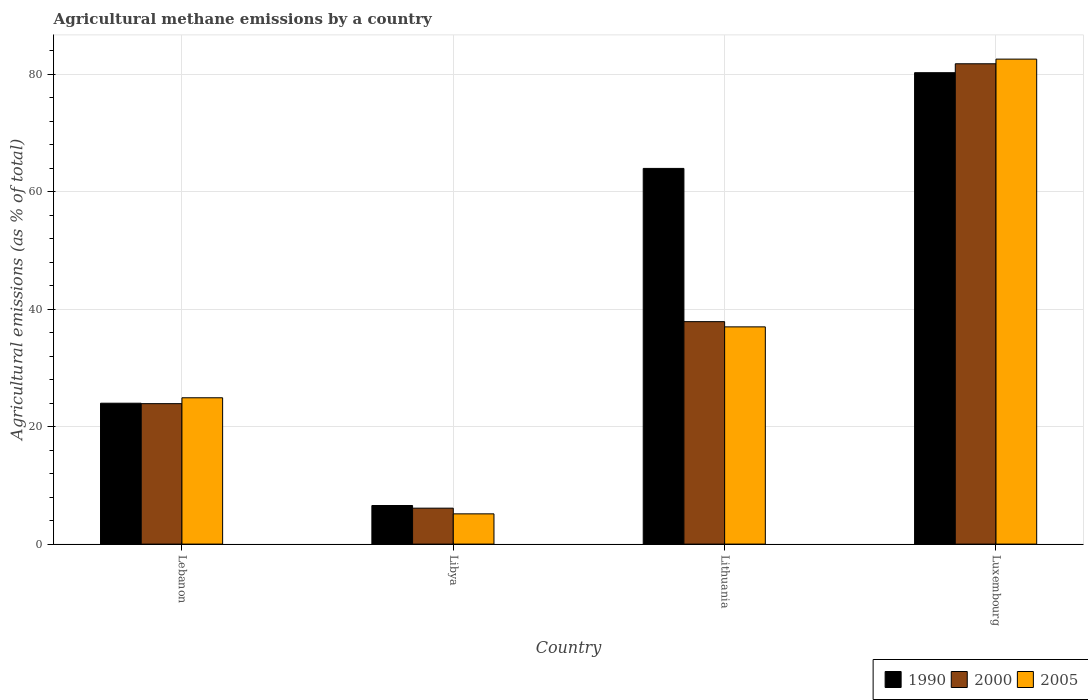Are the number of bars on each tick of the X-axis equal?
Keep it short and to the point. Yes. What is the label of the 4th group of bars from the left?
Provide a succinct answer. Luxembourg. In how many cases, is the number of bars for a given country not equal to the number of legend labels?
Offer a terse response. 0. What is the amount of agricultural methane emitted in 1990 in Luxembourg?
Provide a succinct answer. 80.22. Across all countries, what is the maximum amount of agricultural methane emitted in 2000?
Keep it short and to the point. 81.74. Across all countries, what is the minimum amount of agricultural methane emitted in 1990?
Your answer should be compact. 6.57. In which country was the amount of agricultural methane emitted in 2005 maximum?
Your answer should be very brief. Luxembourg. In which country was the amount of agricultural methane emitted in 2005 minimum?
Make the answer very short. Libya. What is the total amount of agricultural methane emitted in 2000 in the graph?
Provide a short and direct response. 149.62. What is the difference between the amount of agricultural methane emitted in 2005 in Libya and that in Lithuania?
Give a very brief answer. -31.82. What is the difference between the amount of agricultural methane emitted in 2005 in Luxembourg and the amount of agricultural methane emitted in 1990 in Lithuania?
Your answer should be compact. 18.6. What is the average amount of agricultural methane emitted in 2005 per country?
Your answer should be compact. 37.39. What is the difference between the amount of agricultural methane emitted of/in 2005 and amount of agricultural methane emitted of/in 1990 in Lithuania?
Offer a very short reply. -26.97. In how many countries, is the amount of agricultural methane emitted in 2000 greater than 60 %?
Your answer should be compact. 1. What is the ratio of the amount of agricultural methane emitted in 2000 in Libya to that in Lithuania?
Offer a terse response. 0.16. Is the amount of agricultural methane emitted in 1990 in Lebanon less than that in Lithuania?
Offer a very short reply. Yes. What is the difference between the highest and the second highest amount of agricultural methane emitted in 2005?
Provide a short and direct response. -57.63. What is the difference between the highest and the lowest amount of agricultural methane emitted in 2005?
Your response must be concise. 77.39. Is the sum of the amount of agricultural methane emitted in 1990 in Lithuania and Luxembourg greater than the maximum amount of agricultural methane emitted in 2000 across all countries?
Provide a succinct answer. Yes. What does the 1st bar from the left in Luxembourg represents?
Give a very brief answer. 1990. Is it the case that in every country, the sum of the amount of agricultural methane emitted in 2000 and amount of agricultural methane emitted in 1990 is greater than the amount of agricultural methane emitted in 2005?
Ensure brevity in your answer.  Yes. How many bars are there?
Ensure brevity in your answer.  12. Are all the bars in the graph horizontal?
Your answer should be very brief. No. How many countries are there in the graph?
Offer a very short reply. 4. What is the difference between two consecutive major ticks on the Y-axis?
Keep it short and to the point. 20. Are the values on the major ticks of Y-axis written in scientific E-notation?
Your answer should be very brief. No. Does the graph contain any zero values?
Provide a succinct answer. No. Does the graph contain grids?
Offer a very short reply. Yes. How are the legend labels stacked?
Keep it short and to the point. Horizontal. What is the title of the graph?
Make the answer very short. Agricultural methane emissions by a country. What is the label or title of the X-axis?
Give a very brief answer. Country. What is the label or title of the Y-axis?
Keep it short and to the point. Agricultural emissions (as % of total). What is the Agricultural emissions (as % of total) in 1990 in Lebanon?
Keep it short and to the point. 23.98. What is the Agricultural emissions (as % of total) of 2000 in Lebanon?
Give a very brief answer. 23.9. What is the Agricultural emissions (as % of total) of 2005 in Lebanon?
Offer a terse response. 24.9. What is the Agricultural emissions (as % of total) in 1990 in Libya?
Offer a very short reply. 6.57. What is the Agricultural emissions (as % of total) of 2000 in Libya?
Offer a very short reply. 6.12. What is the Agricultural emissions (as % of total) of 2005 in Libya?
Offer a very short reply. 5.15. What is the Agricultural emissions (as % of total) in 1990 in Lithuania?
Make the answer very short. 63.93. What is the Agricultural emissions (as % of total) in 2000 in Lithuania?
Offer a terse response. 37.86. What is the Agricultural emissions (as % of total) in 2005 in Lithuania?
Give a very brief answer. 36.97. What is the Agricultural emissions (as % of total) of 1990 in Luxembourg?
Provide a short and direct response. 80.22. What is the Agricultural emissions (as % of total) in 2000 in Luxembourg?
Ensure brevity in your answer.  81.74. What is the Agricultural emissions (as % of total) in 2005 in Luxembourg?
Make the answer very short. 82.53. Across all countries, what is the maximum Agricultural emissions (as % of total) of 1990?
Your answer should be compact. 80.22. Across all countries, what is the maximum Agricultural emissions (as % of total) in 2000?
Your answer should be compact. 81.74. Across all countries, what is the maximum Agricultural emissions (as % of total) in 2005?
Make the answer very short. 82.53. Across all countries, what is the minimum Agricultural emissions (as % of total) in 1990?
Make the answer very short. 6.57. Across all countries, what is the minimum Agricultural emissions (as % of total) of 2000?
Provide a short and direct response. 6.12. Across all countries, what is the minimum Agricultural emissions (as % of total) of 2005?
Your answer should be compact. 5.15. What is the total Agricultural emissions (as % of total) of 1990 in the graph?
Your response must be concise. 174.7. What is the total Agricultural emissions (as % of total) in 2000 in the graph?
Your response must be concise. 149.62. What is the total Agricultural emissions (as % of total) of 2005 in the graph?
Your answer should be very brief. 149.55. What is the difference between the Agricultural emissions (as % of total) in 1990 in Lebanon and that in Libya?
Your answer should be very brief. 17.41. What is the difference between the Agricultural emissions (as % of total) of 2000 in Lebanon and that in Libya?
Your answer should be very brief. 17.79. What is the difference between the Agricultural emissions (as % of total) of 2005 in Lebanon and that in Libya?
Make the answer very short. 19.76. What is the difference between the Agricultural emissions (as % of total) of 1990 in Lebanon and that in Lithuania?
Provide a succinct answer. -39.96. What is the difference between the Agricultural emissions (as % of total) of 2000 in Lebanon and that in Lithuania?
Offer a very short reply. -13.95. What is the difference between the Agricultural emissions (as % of total) in 2005 in Lebanon and that in Lithuania?
Offer a terse response. -12.07. What is the difference between the Agricultural emissions (as % of total) in 1990 in Lebanon and that in Luxembourg?
Your answer should be very brief. -56.25. What is the difference between the Agricultural emissions (as % of total) in 2000 in Lebanon and that in Luxembourg?
Provide a succinct answer. -57.84. What is the difference between the Agricultural emissions (as % of total) in 2005 in Lebanon and that in Luxembourg?
Provide a succinct answer. -57.63. What is the difference between the Agricultural emissions (as % of total) of 1990 in Libya and that in Lithuania?
Offer a very short reply. -57.37. What is the difference between the Agricultural emissions (as % of total) of 2000 in Libya and that in Lithuania?
Your response must be concise. -31.74. What is the difference between the Agricultural emissions (as % of total) of 2005 in Libya and that in Lithuania?
Offer a terse response. -31.82. What is the difference between the Agricultural emissions (as % of total) in 1990 in Libya and that in Luxembourg?
Keep it short and to the point. -73.65. What is the difference between the Agricultural emissions (as % of total) in 2000 in Libya and that in Luxembourg?
Give a very brief answer. -75.63. What is the difference between the Agricultural emissions (as % of total) of 2005 in Libya and that in Luxembourg?
Offer a very short reply. -77.39. What is the difference between the Agricultural emissions (as % of total) of 1990 in Lithuania and that in Luxembourg?
Make the answer very short. -16.29. What is the difference between the Agricultural emissions (as % of total) in 2000 in Lithuania and that in Luxembourg?
Offer a very short reply. -43.88. What is the difference between the Agricultural emissions (as % of total) in 2005 in Lithuania and that in Luxembourg?
Offer a terse response. -45.56. What is the difference between the Agricultural emissions (as % of total) of 1990 in Lebanon and the Agricultural emissions (as % of total) of 2000 in Libya?
Keep it short and to the point. 17.86. What is the difference between the Agricultural emissions (as % of total) of 1990 in Lebanon and the Agricultural emissions (as % of total) of 2005 in Libya?
Your answer should be compact. 18.83. What is the difference between the Agricultural emissions (as % of total) in 2000 in Lebanon and the Agricultural emissions (as % of total) in 2005 in Libya?
Provide a short and direct response. 18.76. What is the difference between the Agricultural emissions (as % of total) in 1990 in Lebanon and the Agricultural emissions (as % of total) in 2000 in Lithuania?
Your answer should be compact. -13.88. What is the difference between the Agricultural emissions (as % of total) of 1990 in Lebanon and the Agricultural emissions (as % of total) of 2005 in Lithuania?
Make the answer very short. -12.99. What is the difference between the Agricultural emissions (as % of total) in 2000 in Lebanon and the Agricultural emissions (as % of total) in 2005 in Lithuania?
Ensure brevity in your answer.  -13.07. What is the difference between the Agricultural emissions (as % of total) of 1990 in Lebanon and the Agricultural emissions (as % of total) of 2000 in Luxembourg?
Provide a succinct answer. -57.76. What is the difference between the Agricultural emissions (as % of total) of 1990 in Lebanon and the Agricultural emissions (as % of total) of 2005 in Luxembourg?
Ensure brevity in your answer.  -58.56. What is the difference between the Agricultural emissions (as % of total) in 2000 in Lebanon and the Agricultural emissions (as % of total) in 2005 in Luxembourg?
Make the answer very short. -58.63. What is the difference between the Agricultural emissions (as % of total) in 1990 in Libya and the Agricultural emissions (as % of total) in 2000 in Lithuania?
Your answer should be very brief. -31.29. What is the difference between the Agricultural emissions (as % of total) of 1990 in Libya and the Agricultural emissions (as % of total) of 2005 in Lithuania?
Your answer should be compact. -30.4. What is the difference between the Agricultural emissions (as % of total) of 2000 in Libya and the Agricultural emissions (as % of total) of 2005 in Lithuania?
Offer a very short reply. -30.85. What is the difference between the Agricultural emissions (as % of total) in 1990 in Libya and the Agricultural emissions (as % of total) in 2000 in Luxembourg?
Your response must be concise. -75.17. What is the difference between the Agricultural emissions (as % of total) in 1990 in Libya and the Agricultural emissions (as % of total) in 2005 in Luxembourg?
Keep it short and to the point. -75.97. What is the difference between the Agricultural emissions (as % of total) of 2000 in Libya and the Agricultural emissions (as % of total) of 2005 in Luxembourg?
Make the answer very short. -76.42. What is the difference between the Agricultural emissions (as % of total) of 1990 in Lithuania and the Agricultural emissions (as % of total) of 2000 in Luxembourg?
Give a very brief answer. -17.81. What is the difference between the Agricultural emissions (as % of total) of 1990 in Lithuania and the Agricultural emissions (as % of total) of 2005 in Luxembourg?
Provide a short and direct response. -18.6. What is the difference between the Agricultural emissions (as % of total) of 2000 in Lithuania and the Agricultural emissions (as % of total) of 2005 in Luxembourg?
Provide a short and direct response. -44.68. What is the average Agricultural emissions (as % of total) in 1990 per country?
Keep it short and to the point. 43.68. What is the average Agricultural emissions (as % of total) in 2000 per country?
Provide a short and direct response. 37.4. What is the average Agricultural emissions (as % of total) of 2005 per country?
Offer a terse response. 37.39. What is the difference between the Agricultural emissions (as % of total) of 1990 and Agricultural emissions (as % of total) of 2000 in Lebanon?
Provide a succinct answer. 0.07. What is the difference between the Agricultural emissions (as % of total) of 1990 and Agricultural emissions (as % of total) of 2005 in Lebanon?
Your response must be concise. -0.93. What is the difference between the Agricultural emissions (as % of total) in 2000 and Agricultural emissions (as % of total) in 2005 in Lebanon?
Make the answer very short. -1. What is the difference between the Agricultural emissions (as % of total) of 1990 and Agricultural emissions (as % of total) of 2000 in Libya?
Offer a terse response. 0.45. What is the difference between the Agricultural emissions (as % of total) in 1990 and Agricultural emissions (as % of total) in 2005 in Libya?
Offer a terse response. 1.42. What is the difference between the Agricultural emissions (as % of total) in 2000 and Agricultural emissions (as % of total) in 2005 in Libya?
Offer a very short reply. 0.97. What is the difference between the Agricultural emissions (as % of total) in 1990 and Agricultural emissions (as % of total) in 2000 in Lithuania?
Ensure brevity in your answer.  26.08. What is the difference between the Agricultural emissions (as % of total) of 1990 and Agricultural emissions (as % of total) of 2005 in Lithuania?
Your answer should be compact. 26.97. What is the difference between the Agricultural emissions (as % of total) of 2000 and Agricultural emissions (as % of total) of 2005 in Lithuania?
Give a very brief answer. 0.89. What is the difference between the Agricultural emissions (as % of total) in 1990 and Agricultural emissions (as % of total) in 2000 in Luxembourg?
Make the answer very short. -1.52. What is the difference between the Agricultural emissions (as % of total) of 1990 and Agricultural emissions (as % of total) of 2005 in Luxembourg?
Offer a terse response. -2.31. What is the difference between the Agricultural emissions (as % of total) of 2000 and Agricultural emissions (as % of total) of 2005 in Luxembourg?
Your answer should be very brief. -0.79. What is the ratio of the Agricultural emissions (as % of total) in 1990 in Lebanon to that in Libya?
Offer a terse response. 3.65. What is the ratio of the Agricultural emissions (as % of total) of 2000 in Lebanon to that in Libya?
Provide a short and direct response. 3.91. What is the ratio of the Agricultural emissions (as % of total) of 2005 in Lebanon to that in Libya?
Your response must be concise. 4.84. What is the ratio of the Agricultural emissions (as % of total) in 2000 in Lebanon to that in Lithuania?
Provide a short and direct response. 0.63. What is the ratio of the Agricultural emissions (as % of total) in 2005 in Lebanon to that in Lithuania?
Keep it short and to the point. 0.67. What is the ratio of the Agricultural emissions (as % of total) of 1990 in Lebanon to that in Luxembourg?
Your answer should be compact. 0.3. What is the ratio of the Agricultural emissions (as % of total) in 2000 in Lebanon to that in Luxembourg?
Provide a succinct answer. 0.29. What is the ratio of the Agricultural emissions (as % of total) of 2005 in Lebanon to that in Luxembourg?
Provide a succinct answer. 0.3. What is the ratio of the Agricultural emissions (as % of total) of 1990 in Libya to that in Lithuania?
Make the answer very short. 0.1. What is the ratio of the Agricultural emissions (as % of total) in 2000 in Libya to that in Lithuania?
Make the answer very short. 0.16. What is the ratio of the Agricultural emissions (as % of total) in 2005 in Libya to that in Lithuania?
Your answer should be compact. 0.14. What is the ratio of the Agricultural emissions (as % of total) in 1990 in Libya to that in Luxembourg?
Offer a very short reply. 0.08. What is the ratio of the Agricultural emissions (as % of total) in 2000 in Libya to that in Luxembourg?
Offer a very short reply. 0.07. What is the ratio of the Agricultural emissions (as % of total) of 2005 in Libya to that in Luxembourg?
Provide a short and direct response. 0.06. What is the ratio of the Agricultural emissions (as % of total) of 1990 in Lithuania to that in Luxembourg?
Provide a short and direct response. 0.8. What is the ratio of the Agricultural emissions (as % of total) of 2000 in Lithuania to that in Luxembourg?
Your response must be concise. 0.46. What is the ratio of the Agricultural emissions (as % of total) in 2005 in Lithuania to that in Luxembourg?
Make the answer very short. 0.45. What is the difference between the highest and the second highest Agricultural emissions (as % of total) in 1990?
Provide a short and direct response. 16.29. What is the difference between the highest and the second highest Agricultural emissions (as % of total) of 2000?
Make the answer very short. 43.88. What is the difference between the highest and the second highest Agricultural emissions (as % of total) of 2005?
Make the answer very short. 45.56. What is the difference between the highest and the lowest Agricultural emissions (as % of total) of 1990?
Provide a succinct answer. 73.65. What is the difference between the highest and the lowest Agricultural emissions (as % of total) in 2000?
Provide a succinct answer. 75.63. What is the difference between the highest and the lowest Agricultural emissions (as % of total) in 2005?
Give a very brief answer. 77.39. 